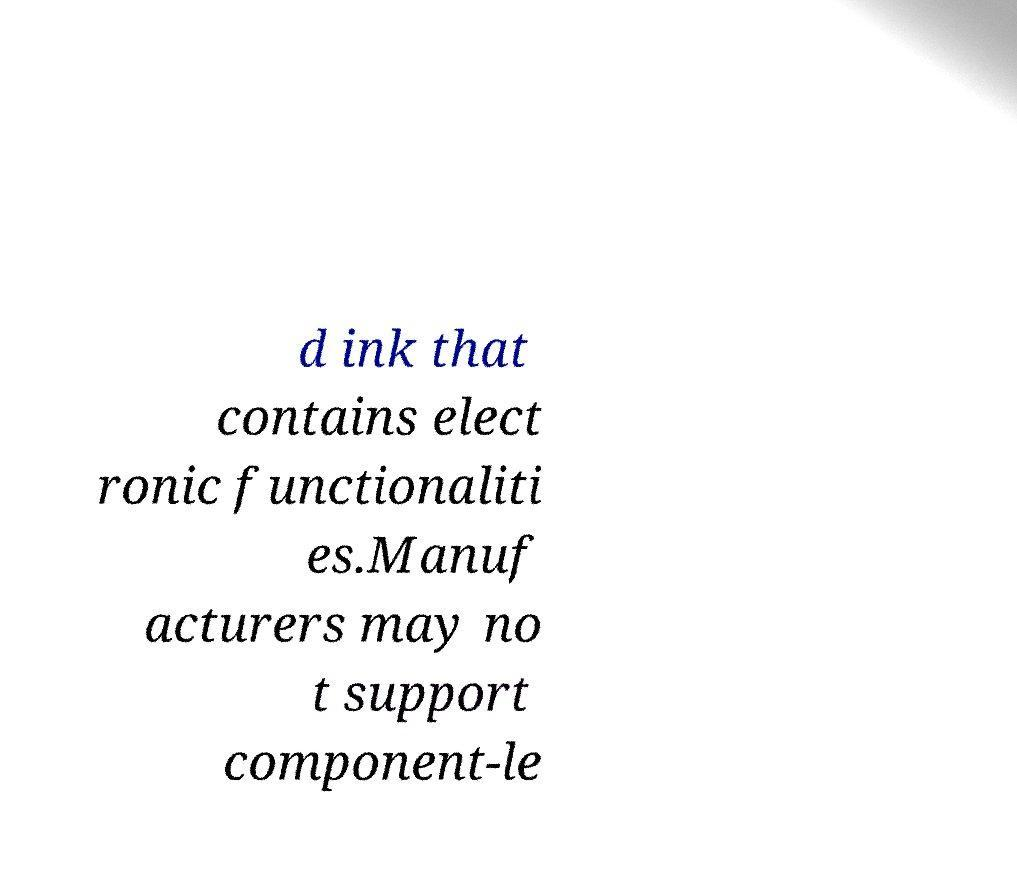Please identify and transcribe the text found in this image. d ink that contains elect ronic functionaliti es.Manuf acturers may no t support component-le 